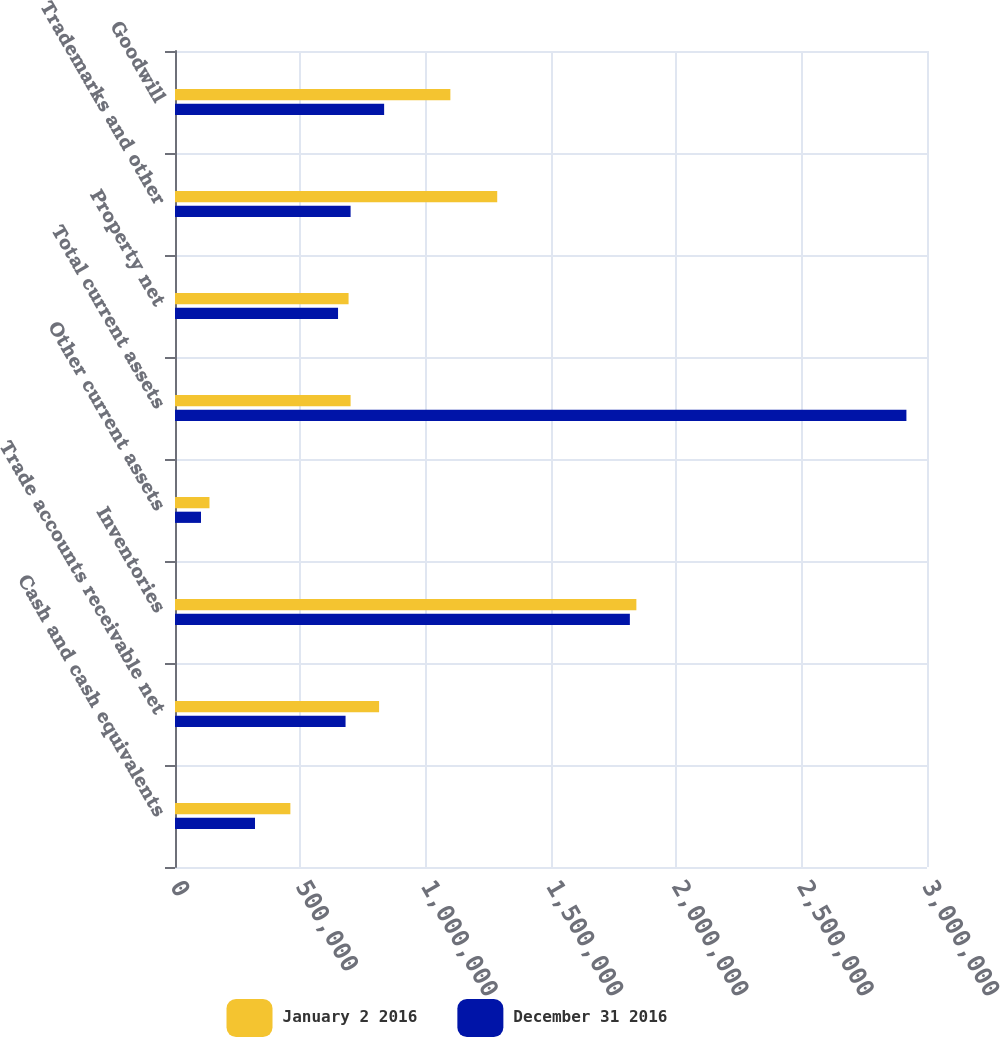<chart> <loc_0><loc_0><loc_500><loc_500><stacked_bar_chart><ecel><fcel>Cash and cash equivalents<fcel>Trade accounts receivable net<fcel>Inventories<fcel>Other current assets<fcel>Total current assets<fcel>Property net<fcel>Trademarks and other<fcel>Goodwill<nl><fcel>January 2 2016<fcel>460245<fcel>814178<fcel>1.84056e+06<fcel>137535<fcel>700515<fcel>692464<fcel>1.28546e+06<fcel>1.09854e+06<nl><fcel>December 31 2016<fcel>319169<fcel>680417<fcel>1.8146e+06<fcel>103679<fcel>2.91787e+06<fcel>650462<fcel>700515<fcel>834315<nl></chart> 